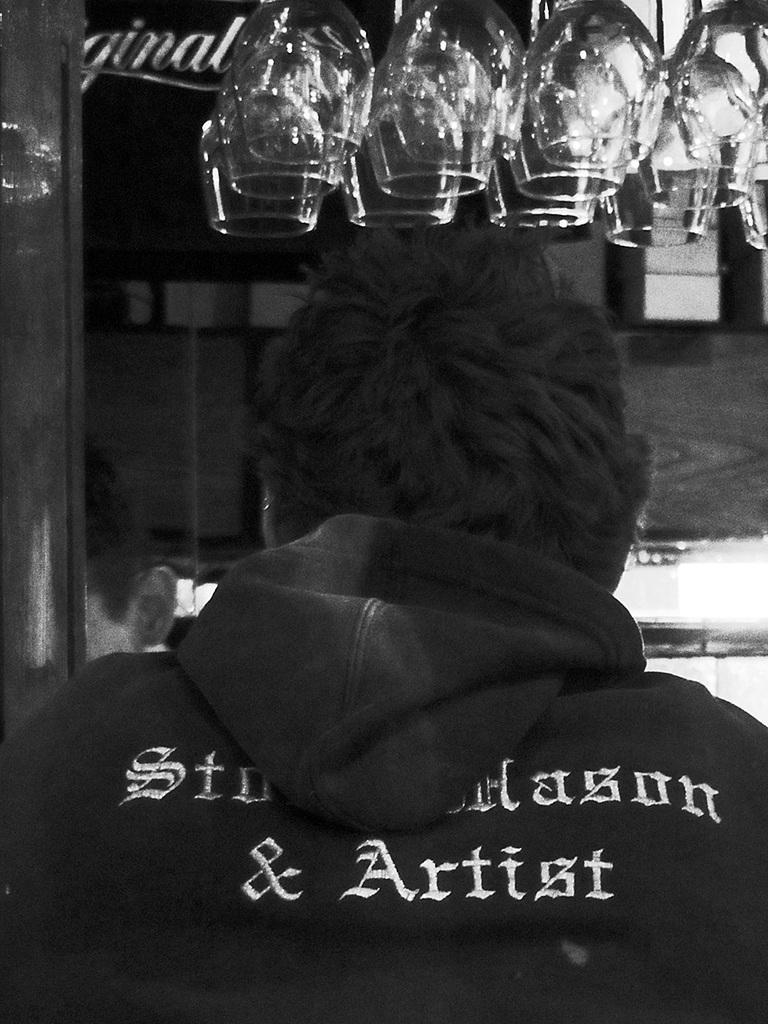Could you give a brief overview of what you see in this image? In this image I can see a person, background I can see few glasses and the image is in black and white. 